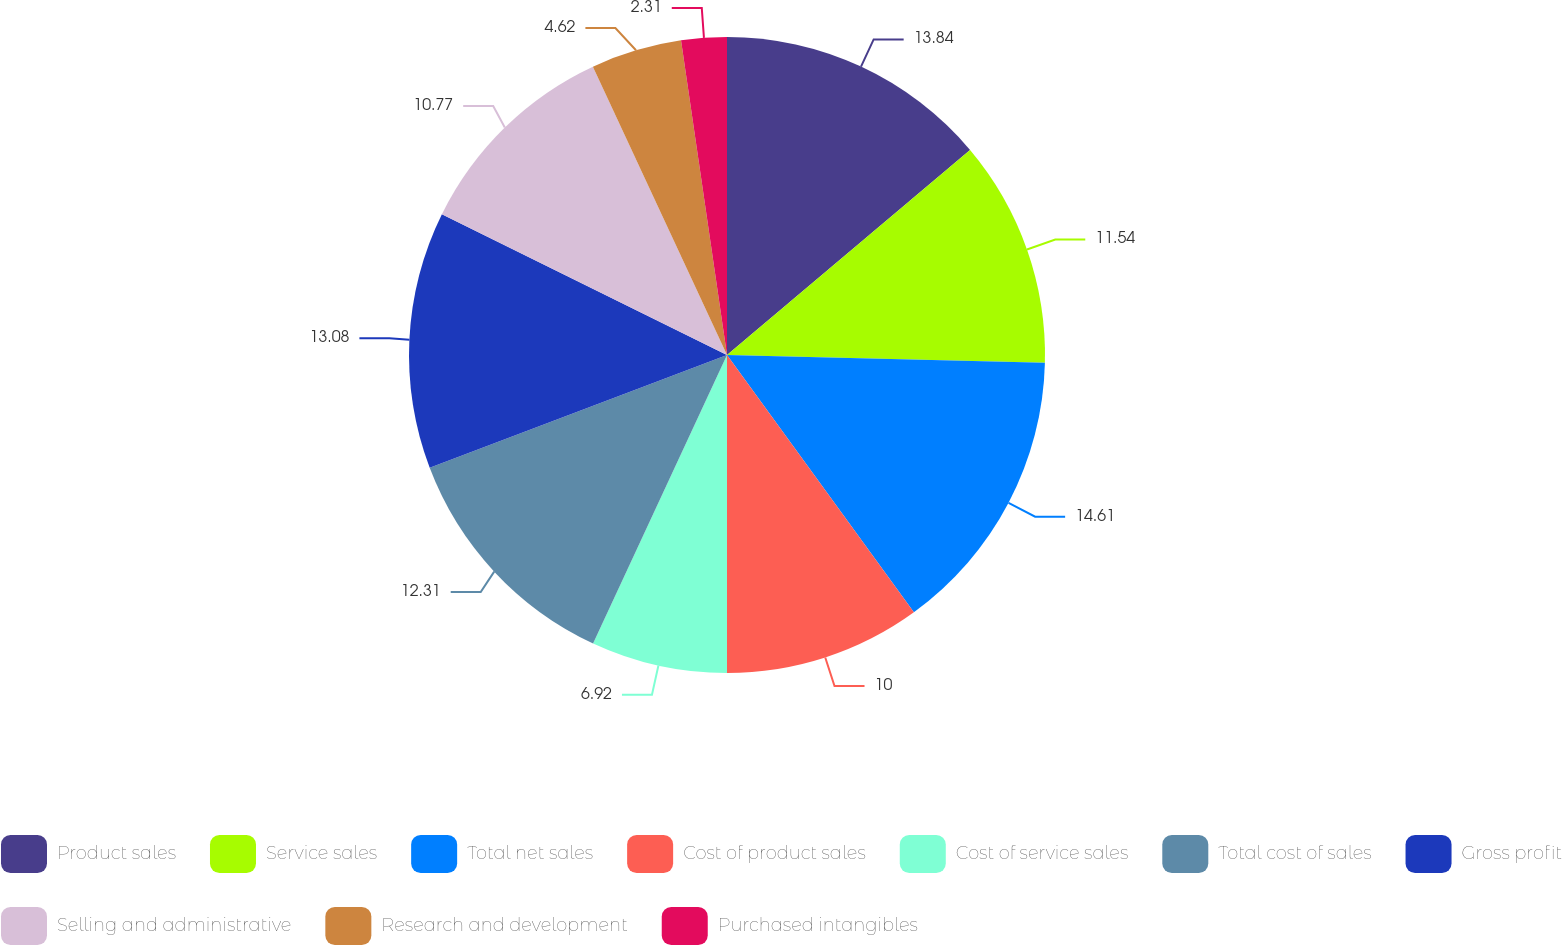<chart> <loc_0><loc_0><loc_500><loc_500><pie_chart><fcel>Product sales<fcel>Service sales<fcel>Total net sales<fcel>Cost of product sales<fcel>Cost of service sales<fcel>Total cost of sales<fcel>Gross profit<fcel>Selling and administrative<fcel>Research and development<fcel>Purchased intangibles<nl><fcel>13.85%<fcel>11.54%<fcel>14.62%<fcel>10.0%<fcel>6.92%<fcel>12.31%<fcel>13.08%<fcel>10.77%<fcel>4.62%<fcel>2.31%<nl></chart> 